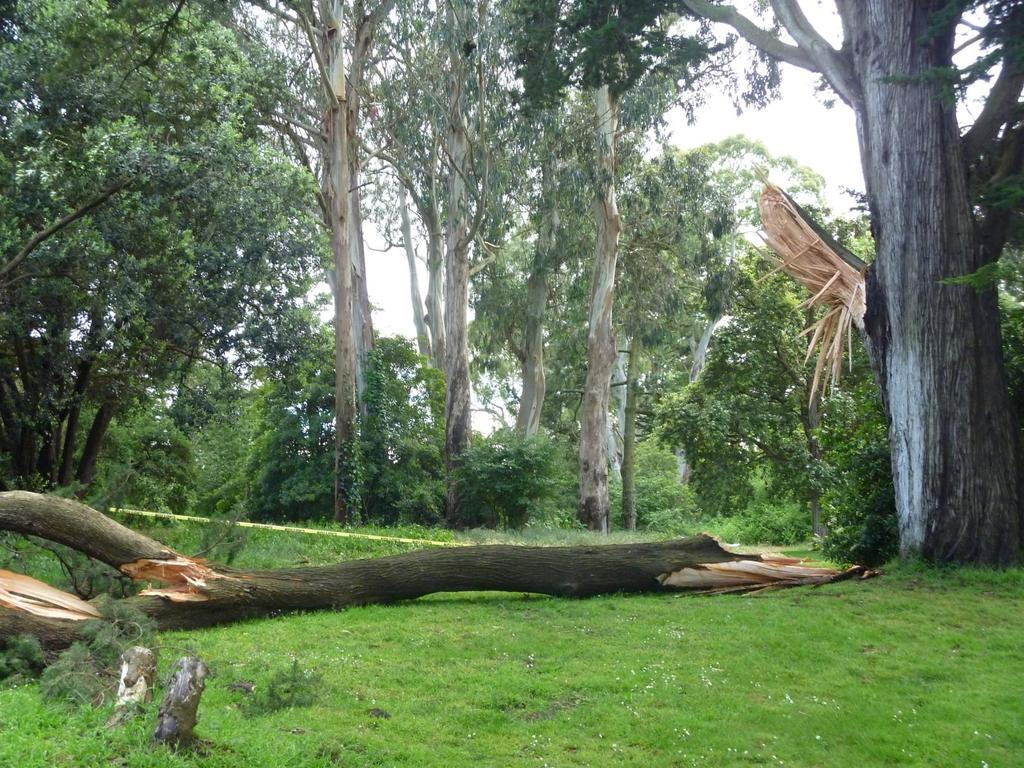What is the main subject of the image? The main subject of the image is a forest. Can you describe any specific features or objects in the image? Yes, there is a broken tree trunk lying on the ground in the front of the image. What can be seen in the background of the image? There are many huge trees visible in the background of the image. What type of pies can be seen hanging from the branches of the trees in the image? There are no pies present in the image; it features a forest with a broken tree trunk and many huge trees in the background. 